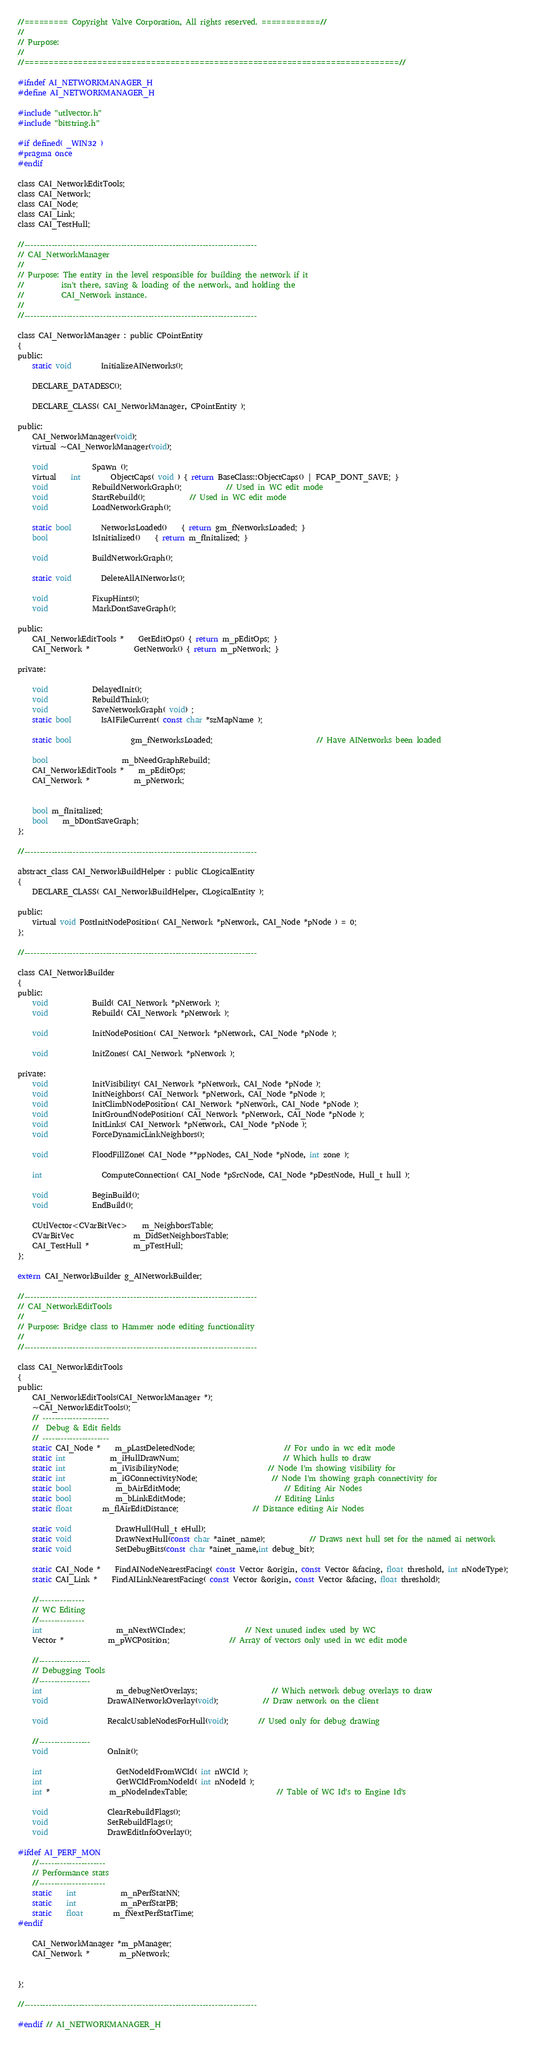Convert code to text. <code><loc_0><loc_0><loc_500><loc_500><_C_>//========= Copyright Valve Corporation, All rights reserved. ============//
//
// Purpose:
//
//=============================================================================//

#ifndef AI_NETWORKMANAGER_H
#define AI_NETWORKMANAGER_H

#include "utlvector.h"
#include "bitstring.h"

#if defined( _WIN32 )
#pragma once
#endif

class CAI_NetworkEditTools;
class CAI_Network;
class CAI_Node;
class CAI_Link;
class CAI_TestHull;

//-----------------------------------------------------------------------------
// CAI_NetworkManager
//
// Purpose: The entity in the level responsible for building the network if it
//			isn't there, saving & loading of the network, and holding the 
//			CAI_Network instance.
//
//-----------------------------------------------------------------------------

class CAI_NetworkManager : public CPointEntity
{
public:
	static void		InitializeAINetworks();

	DECLARE_DATADESC();

	DECLARE_CLASS( CAI_NetworkManager, CPointEntity );

public:
	CAI_NetworkManager(void);
	virtual ~CAI_NetworkManager(void);
	
	void			Spawn ();
	virtual	int		ObjectCaps( void ) { return BaseClass::ObjectCaps() | FCAP_DONT_SAVE; }
	void			RebuildNetworkGraph();			// Used in WC edit mode
	void			StartRebuild();			// Used in WC edit mode
	void			LoadNetworkGraph();

	static bool		NetworksLoaded()	{ return gm_fNetworksLoaded; }
	bool			IsInitialized()	{ return m_fInitalized; }

	void			BuildNetworkGraph();

	static void		DeleteAllAINetworks();

	void			FixupHints();
	void			MarkDontSaveGraph();

public:
	CAI_NetworkEditTools *	GetEditOps() { return m_pEditOps; }
	CAI_Network *			GetNetwork() { return m_pNetwork; }
	
private:
	
	void			DelayedInit();
	void			RebuildThink();
	void			SaveNetworkGraph( void) ;	
	static bool		IsAIFileCurrent( const char *szMapName );		
	
	static bool				gm_fNetworksLoaded;							// Have AINetworks been loaded
	
	bool					m_bNeedGraphRebuild;					
	CAI_NetworkEditTools *	m_pEditOps;
	CAI_Network *			m_pNetwork;


	bool m_fInitalized;
	bool	m_bDontSaveGraph;
};

//-----------------------------------------------------------------------------

abstract_class CAI_NetworkBuildHelper : public CLogicalEntity
{
	DECLARE_CLASS( CAI_NetworkBuildHelper, CLogicalEntity );

public:
	virtual void PostInitNodePosition( CAI_Network *pNetwork, CAI_Node *pNode ) = 0;
};

//-----------------------------------------------------------------------------

class CAI_NetworkBuilder
{
public:
	void			Build( CAI_Network *pNetwork );
	void			Rebuild( CAI_Network *pNetwork );

	void			InitNodePosition( CAI_Network *pNetwork, CAI_Node *pNode );

	void			InitZones( CAI_Network *pNetwork );

private:
	void			InitVisibility( CAI_Network *pNetwork, CAI_Node *pNode );
	void			InitNeighbors( CAI_Network *pNetwork, CAI_Node *pNode );
	void			InitClimbNodePosition( CAI_Network *pNetwork, CAI_Node *pNode );
	void			InitGroundNodePosition( CAI_Network *pNetwork, CAI_Node *pNode );
	void			InitLinks( CAI_Network *pNetwork, CAI_Node *pNode );
	void			ForceDynamicLinkNeighbors();
	
	void			FloodFillZone( CAI_Node **ppNodes, CAI_Node *pNode, int zone );

	int				ComputeConnection( CAI_Node *pSrcNode, CAI_Node *pDestNode, Hull_t hull );
	
	void 			BeginBuild();
	void			EndBuild();

	CUtlVector<CVarBitVec>	m_NeighborsTable;
	CVarBitVec				m_DidSetNeighborsTable;
	CAI_TestHull *			m_pTestHull;
};

extern CAI_NetworkBuilder g_AINetworkBuilder;

//-----------------------------------------------------------------------------
// CAI_NetworkEditTools
//
// Purpose: Bridge class to Hammer node editing functionality
//
//-----------------------------------------------------------------------------

class CAI_NetworkEditTools
{
public:
	CAI_NetworkEditTools(CAI_NetworkManager *);
	~CAI_NetworkEditTools();
	// ----------------------
	//  Debug & Edit fields
	// ----------------------
	static CAI_Node *	m_pLastDeletedNode;						// For undo in wc edit mode
	static int			m_iHullDrawNum;							// Which hulls to draw
	static int			m_iVisibilityNode;						// Node I'm showing visibility for
	static int			m_iGConnectivityNode;					// Node I'm showing graph connectivity for
	static bool			m_bAirEditMode;							// Editing Air Nodes
	static bool			m_bLinkEditMode;						// Editing Links
	static float		m_flAirEditDistance;					// Distance editing Air Nodes

	static void			DrawHull(Hull_t eHull);
	static void			DrawNextHull(const char *ainet_name);			// Draws next hull set for the named ai network
	static void			SetDebugBits(const char *ainet_name,int debug_bit);

	static CAI_Node *	FindAINodeNearestFacing( const Vector &origin, const Vector &facing, float threshold, int nNodeType);
	static CAI_Link *	FindAILinkNearestFacing( const Vector &origin, const Vector &facing, float threshold);						

	//---------------
	// WC Editing 
	//---------------
	int					m_nNextWCIndex;				// Next unused index used by WC
	Vector *			m_pWCPosition;				// Array of vectors only used in wc edit mode

	//-----------------
	// Debugging Tools
	//-----------------
	int					m_debugNetOverlays;					// Which network debug overlays to draw
	void				DrawAINetworkOverlay(void);			// Draw network on the client

	void				RecalcUsableNodesForHull(void);		// Used only for debug drawing

	//-----------------
	void 				OnInit();

	int					GetNodeIdFromWCId( int nWCId );
	int					GetWCIdFromNodeId( int nNodeId );
	int *				m_pNodeIndexTable;						// Table of WC Id's to Engine Id's

	void				ClearRebuildFlags();					
	void				SetRebuildFlags();					
	void				DrawEditInfoOverlay();

#ifdef AI_PERF_MON	
	//----------------------
	// Performance stats
	//----------------------
	static	int			m_nPerfStatNN;
	static	int			m_nPerfStatPB;
	static	float		m_fNextPerfStatTime;
#endif

	CAI_NetworkManager *m_pManager;
	CAI_Network *		m_pNetwork;


};

//-----------------------------------------------------------------------------

#endif // AI_NETWORKMANAGER_H
</code> 